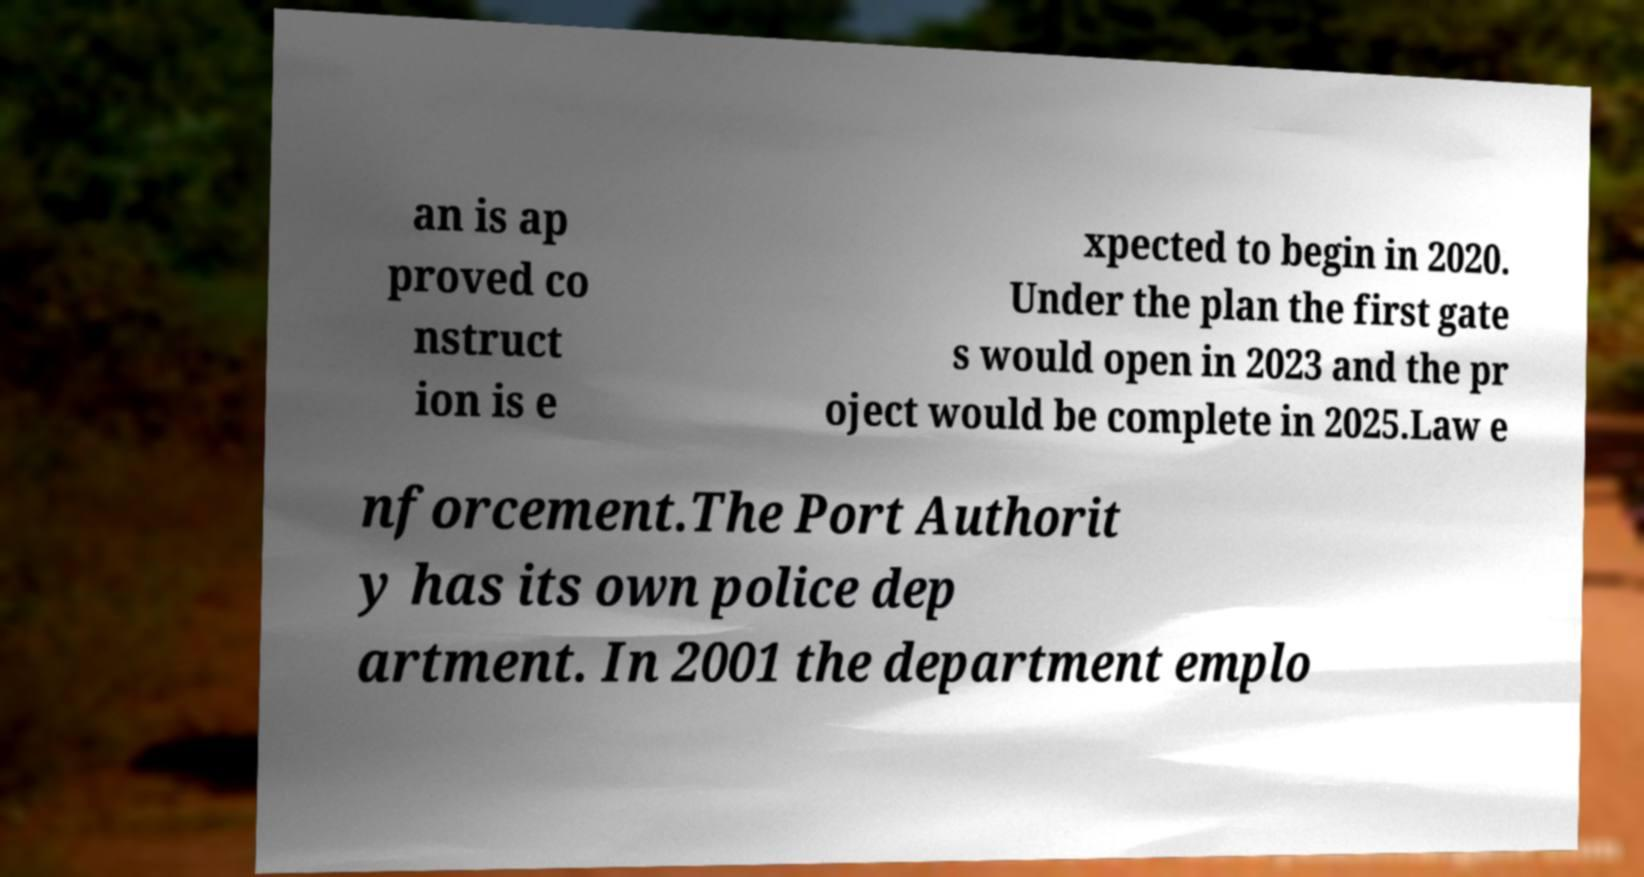I need the written content from this picture converted into text. Can you do that? an is ap proved co nstruct ion is e xpected to begin in 2020. Under the plan the first gate s would open in 2023 and the pr oject would be complete in 2025.Law e nforcement.The Port Authorit y has its own police dep artment. In 2001 the department emplo 